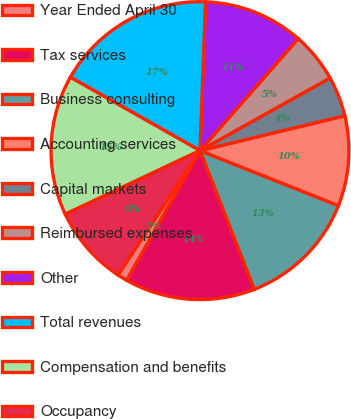Convert chart. <chart><loc_0><loc_0><loc_500><loc_500><pie_chart><fcel>Year Ended April 30<fcel>Tax services<fcel>Business consulting<fcel>Accounting services<fcel>Capital markets<fcel>Reimbursed expenses<fcel>Other<fcel>Total revenues<fcel>Compensation and benefits<fcel>Occupancy<nl><fcel>1.09%<fcel>14.13%<fcel>13.04%<fcel>9.78%<fcel>4.35%<fcel>5.43%<fcel>10.87%<fcel>17.39%<fcel>15.22%<fcel>8.7%<nl></chart> 